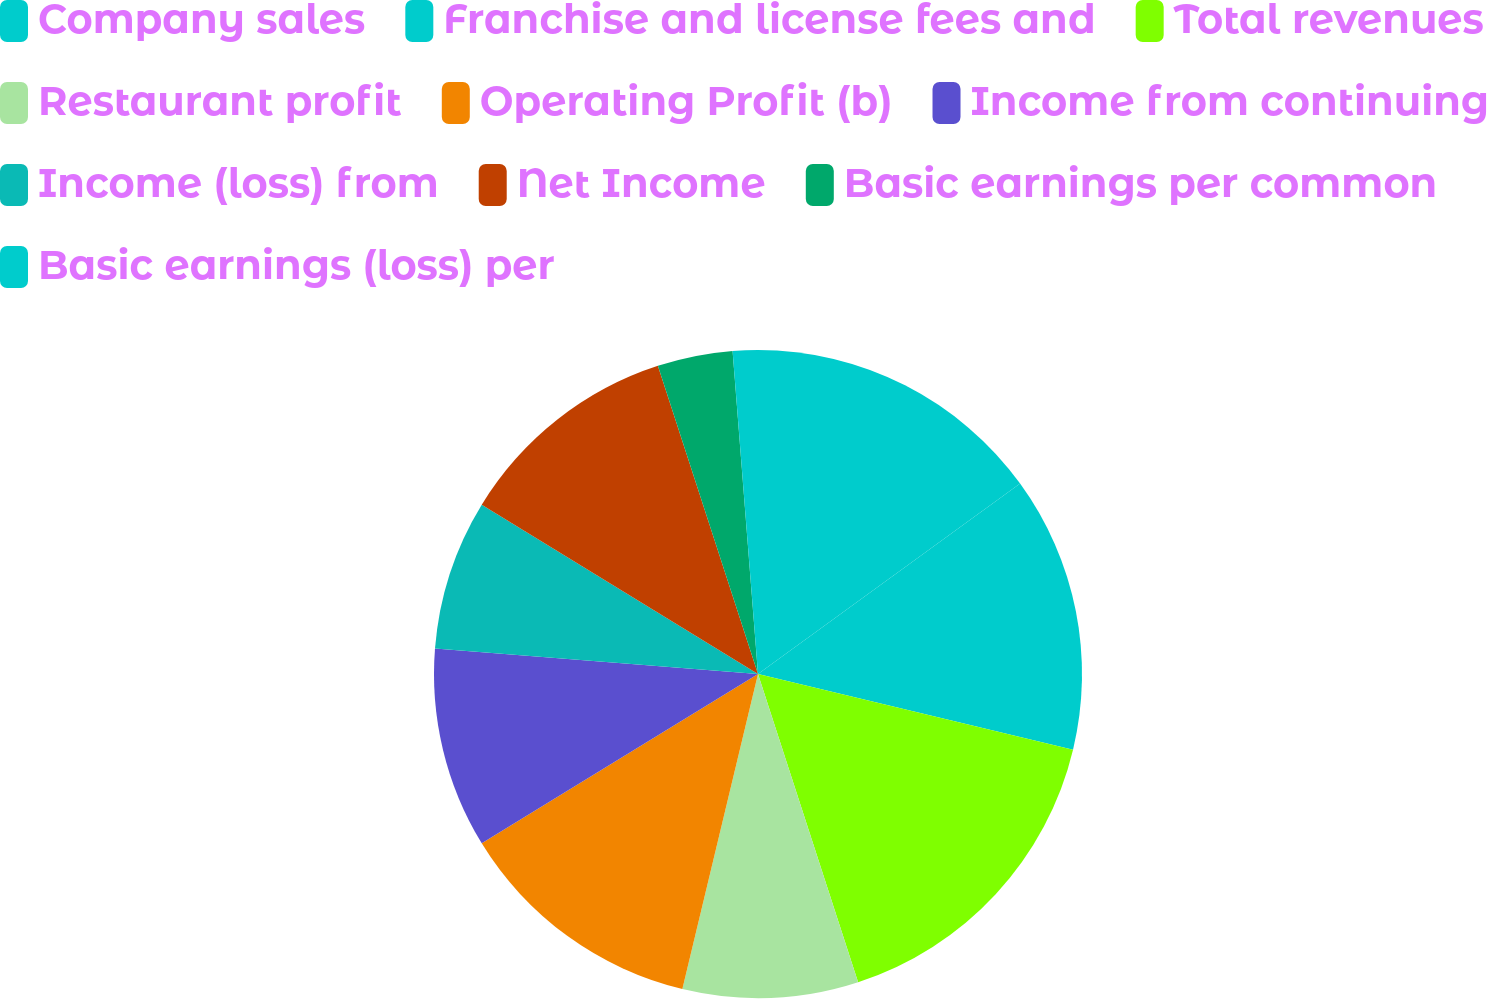<chart> <loc_0><loc_0><loc_500><loc_500><pie_chart><fcel>Company sales<fcel>Franchise and license fees and<fcel>Total revenues<fcel>Restaurant profit<fcel>Operating Profit (b)<fcel>Income from continuing<fcel>Income (loss) from<fcel>Net Income<fcel>Basic earnings per common<fcel>Basic earnings (loss) per<nl><fcel>15.0%<fcel>13.75%<fcel>16.25%<fcel>8.75%<fcel>12.5%<fcel>10.0%<fcel>7.5%<fcel>11.25%<fcel>3.75%<fcel>1.25%<nl></chart> 